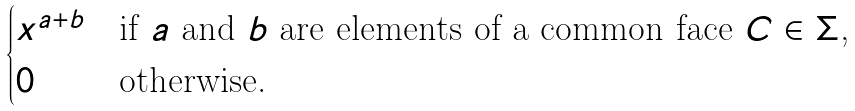<formula> <loc_0><loc_0><loc_500><loc_500>\begin{cases} x ^ { a + b } & \text {if $a$ and $b$ are elements of a common face $C\in \Sigma$,} \\ 0 & \text {otherwise.} \end{cases}</formula> 